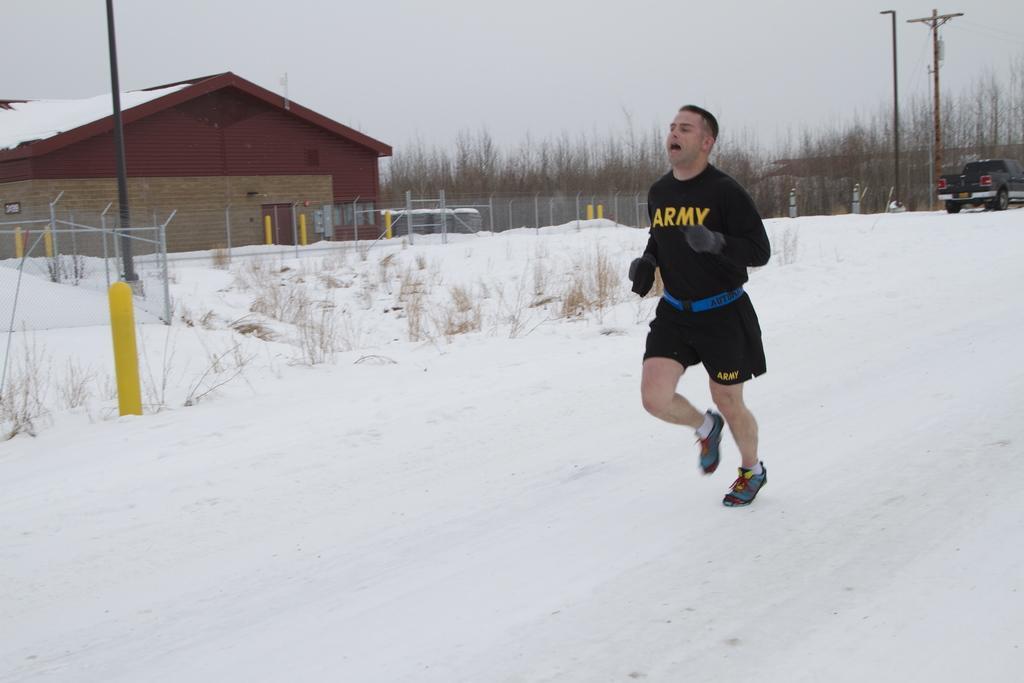How would you summarize this image in a sentence or two? In the image there is a man in black t-shirt and short running in the snow, on the left side there is a godown with fence in front of it and on the right side there are dried trees with a jeep in front of them and above its sky. 